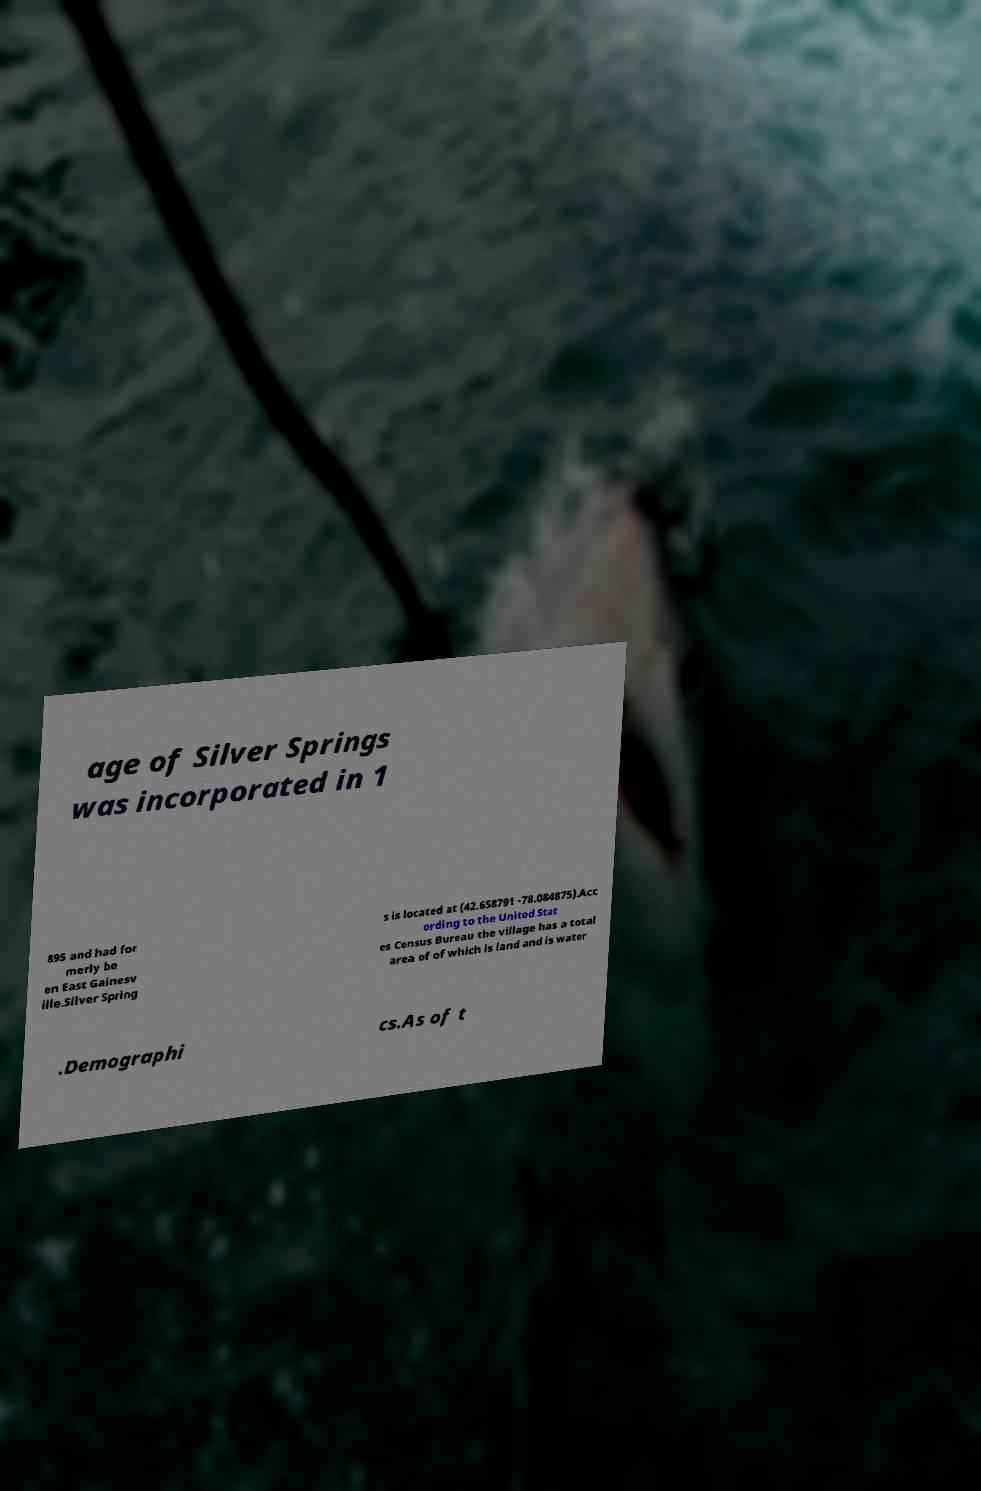Could you assist in decoding the text presented in this image and type it out clearly? age of Silver Springs was incorporated in 1 895 and had for merly be en East Gainesv ille.Silver Spring s is located at (42.658791 -78.084875).Acc ording to the United Stat es Census Bureau the village has a total area of of which is land and is water .Demographi cs.As of t 